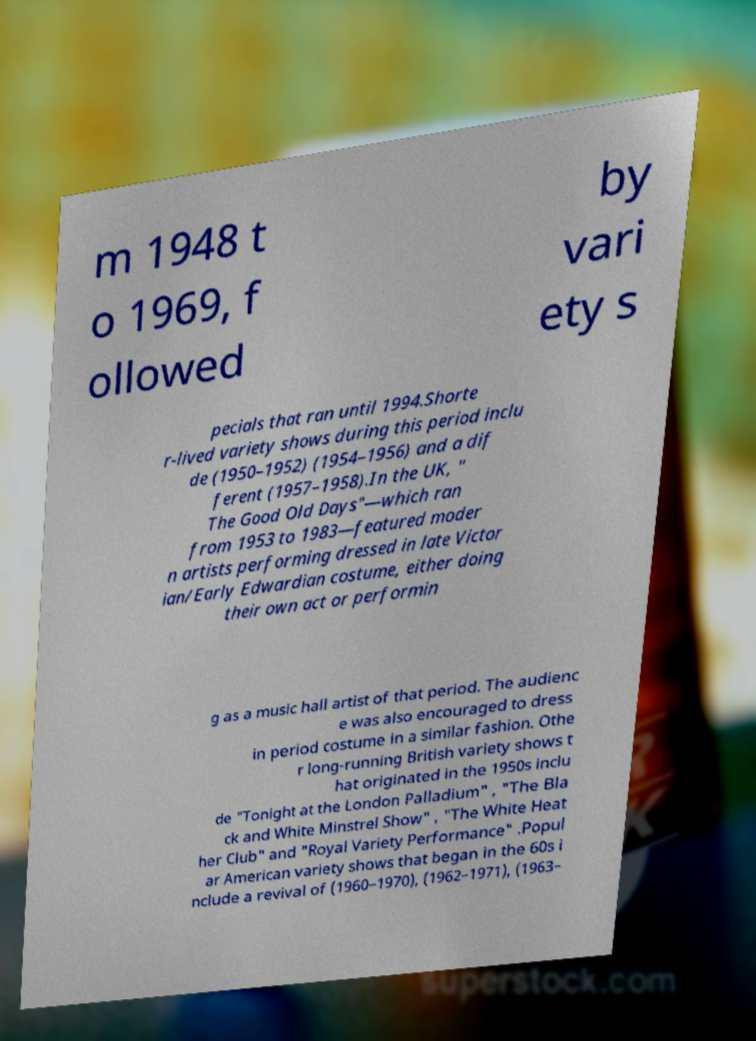Please identify and transcribe the text found in this image. m 1948 t o 1969, f ollowed by vari ety s pecials that ran until 1994.Shorte r-lived variety shows during this period inclu de (1950–1952) (1954–1956) and a dif ferent (1957–1958).In the UK, " The Good Old Days"—which ran from 1953 to 1983—featured moder n artists performing dressed in late Victor ian/Early Edwardian costume, either doing their own act or performin g as a music hall artist of that period. The audienc e was also encouraged to dress in period costume in a similar fashion. Othe r long-running British variety shows t hat originated in the 1950s inclu de "Tonight at the London Palladium" , "The Bla ck and White Minstrel Show" , "The White Heat her Club" and "Royal Variety Performance" .Popul ar American variety shows that began in the 60s i nclude a revival of (1960–1970), (1962–1971), (1963– 